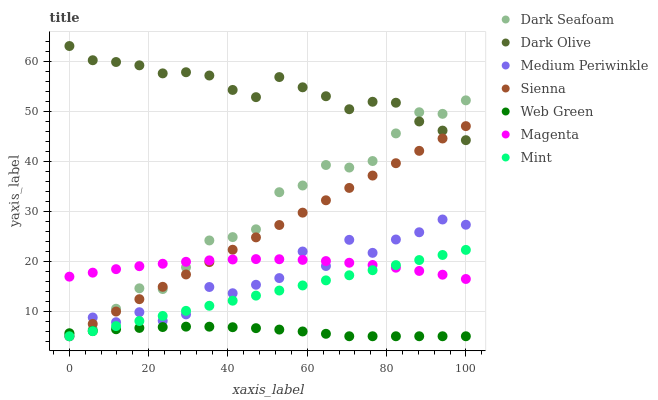Does Web Green have the minimum area under the curve?
Answer yes or no. Yes. Does Dark Olive have the maximum area under the curve?
Answer yes or no. Yes. Does Medium Periwinkle have the minimum area under the curve?
Answer yes or no. No. Does Medium Periwinkle have the maximum area under the curve?
Answer yes or no. No. Is Mint the smoothest?
Answer yes or no. Yes. Is Medium Periwinkle the roughest?
Answer yes or no. Yes. Is Web Green the smoothest?
Answer yes or no. No. Is Web Green the roughest?
Answer yes or no. No. Does Medium Periwinkle have the lowest value?
Answer yes or no. Yes. Does Dark Seafoam have the lowest value?
Answer yes or no. No. Does Dark Olive have the highest value?
Answer yes or no. Yes. Does Medium Periwinkle have the highest value?
Answer yes or no. No. Is Mint less than Dark Seafoam?
Answer yes or no. Yes. Is Dark Olive greater than Web Green?
Answer yes or no. Yes. Does Web Green intersect Medium Periwinkle?
Answer yes or no. Yes. Is Web Green less than Medium Periwinkle?
Answer yes or no. No. Is Web Green greater than Medium Periwinkle?
Answer yes or no. No. Does Mint intersect Dark Seafoam?
Answer yes or no. No. 